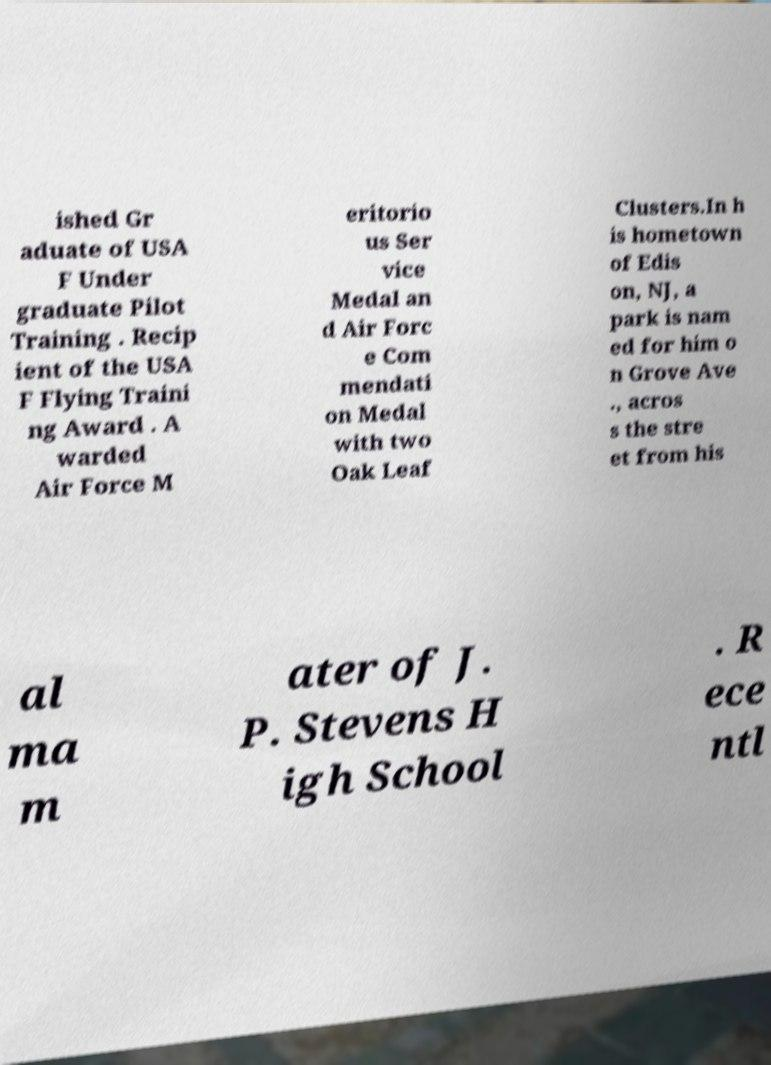Can you read and provide the text displayed in the image?This photo seems to have some interesting text. Can you extract and type it out for me? ished Gr aduate of USA F Under graduate Pilot Training . Recip ient of the USA F Flying Traini ng Award . A warded Air Force M eritorio us Ser vice Medal an d Air Forc e Com mendati on Medal with two Oak Leaf Clusters.In h is hometown of Edis on, NJ, a park is nam ed for him o n Grove Ave ., acros s the stre et from his al ma m ater of J. P. Stevens H igh School . R ece ntl 